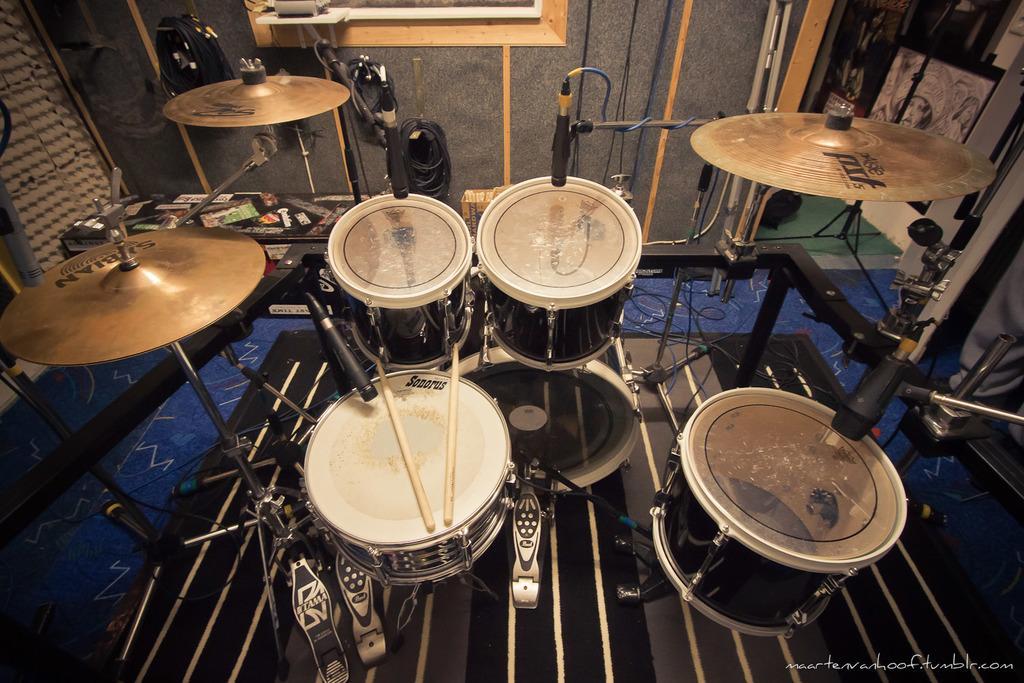Describe this image in one or two sentences. In the image I can see some drums and other musical instruments. 